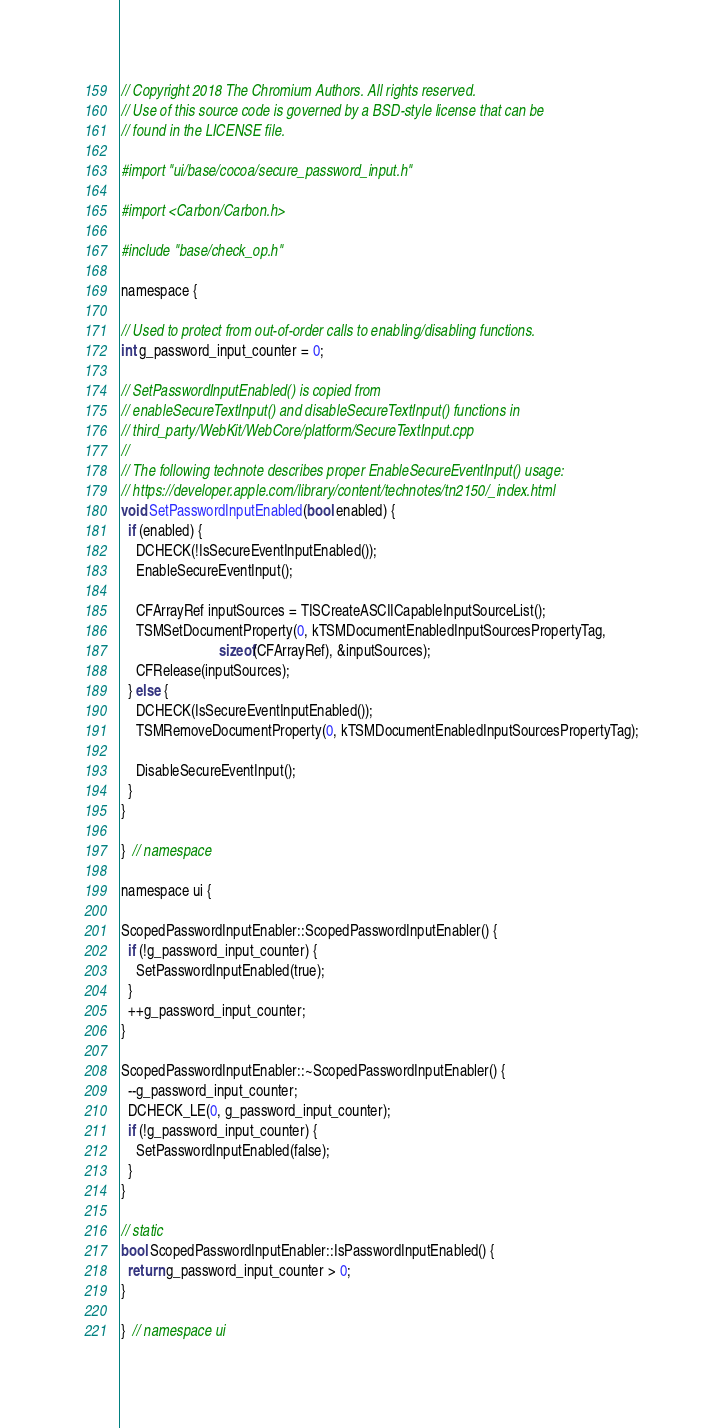<code> <loc_0><loc_0><loc_500><loc_500><_ObjectiveC_>// Copyright 2018 The Chromium Authors. All rights reserved.
// Use of this source code is governed by a BSD-style license that can be
// found in the LICENSE file.

#import "ui/base/cocoa/secure_password_input.h"

#import <Carbon/Carbon.h>

#include "base/check_op.h"

namespace {

// Used to protect from out-of-order calls to enabling/disabling functions.
int g_password_input_counter = 0;

// SetPasswordInputEnabled() is copied from
// enableSecureTextInput() and disableSecureTextInput() functions in
// third_party/WebKit/WebCore/platform/SecureTextInput.cpp
//
// The following technote describes proper EnableSecureEventInput() usage:
// https://developer.apple.com/library/content/technotes/tn2150/_index.html
void SetPasswordInputEnabled(bool enabled) {
  if (enabled) {
    DCHECK(!IsSecureEventInputEnabled());
    EnableSecureEventInput();

    CFArrayRef inputSources = TISCreateASCIICapableInputSourceList();
    TSMSetDocumentProperty(0, kTSMDocumentEnabledInputSourcesPropertyTag,
                           sizeof(CFArrayRef), &inputSources);
    CFRelease(inputSources);
  } else {
    DCHECK(IsSecureEventInputEnabled());
    TSMRemoveDocumentProperty(0, kTSMDocumentEnabledInputSourcesPropertyTag);

    DisableSecureEventInput();
  }
}

}  // namespace

namespace ui {

ScopedPasswordInputEnabler::ScopedPasswordInputEnabler() {
  if (!g_password_input_counter) {
    SetPasswordInputEnabled(true);
  }
  ++g_password_input_counter;
}

ScopedPasswordInputEnabler::~ScopedPasswordInputEnabler() {
  --g_password_input_counter;
  DCHECK_LE(0, g_password_input_counter);
  if (!g_password_input_counter) {
    SetPasswordInputEnabled(false);
  }
}

// static
bool ScopedPasswordInputEnabler::IsPasswordInputEnabled() {
  return g_password_input_counter > 0;
}

}  // namespace ui
</code> 